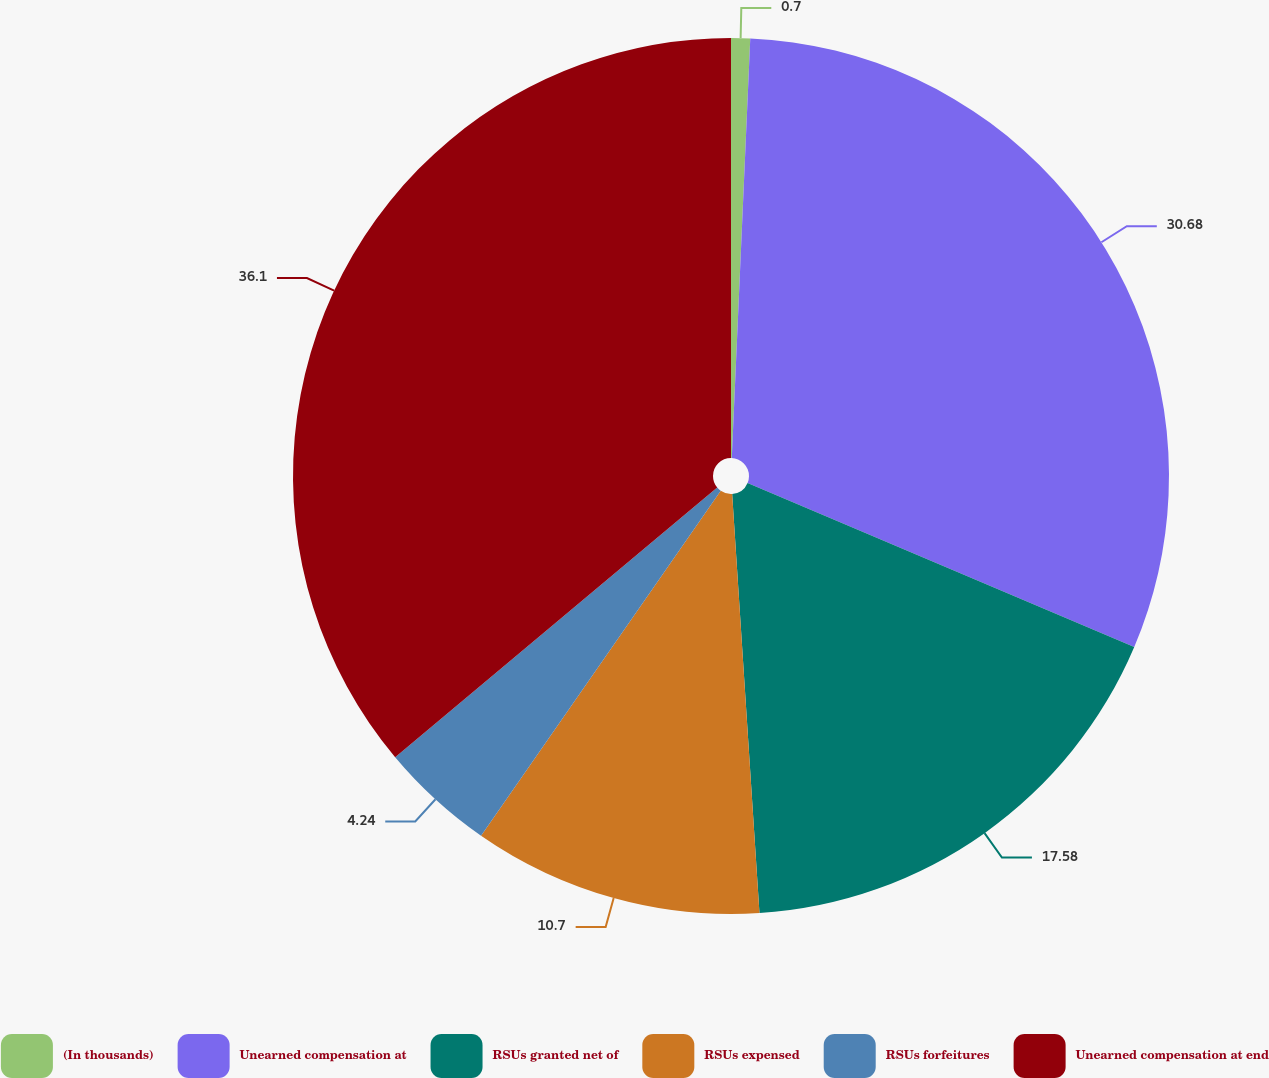Convert chart to OTSL. <chart><loc_0><loc_0><loc_500><loc_500><pie_chart><fcel>(In thousands)<fcel>Unearned compensation at<fcel>RSUs granted net of<fcel>RSUs expensed<fcel>RSUs forfeitures<fcel>Unearned compensation at end<nl><fcel>0.7%<fcel>30.68%<fcel>17.58%<fcel>10.7%<fcel>4.24%<fcel>36.09%<nl></chart> 